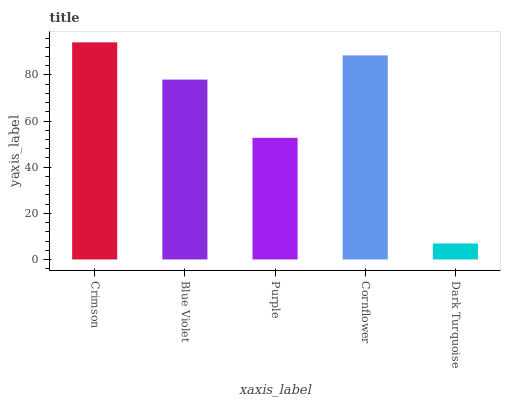Is Dark Turquoise the minimum?
Answer yes or no. Yes. Is Crimson the maximum?
Answer yes or no. Yes. Is Blue Violet the minimum?
Answer yes or no. No. Is Blue Violet the maximum?
Answer yes or no. No. Is Crimson greater than Blue Violet?
Answer yes or no. Yes. Is Blue Violet less than Crimson?
Answer yes or no. Yes. Is Blue Violet greater than Crimson?
Answer yes or no. No. Is Crimson less than Blue Violet?
Answer yes or no. No. Is Blue Violet the high median?
Answer yes or no. Yes. Is Blue Violet the low median?
Answer yes or no. Yes. Is Dark Turquoise the high median?
Answer yes or no. No. Is Cornflower the low median?
Answer yes or no. No. 